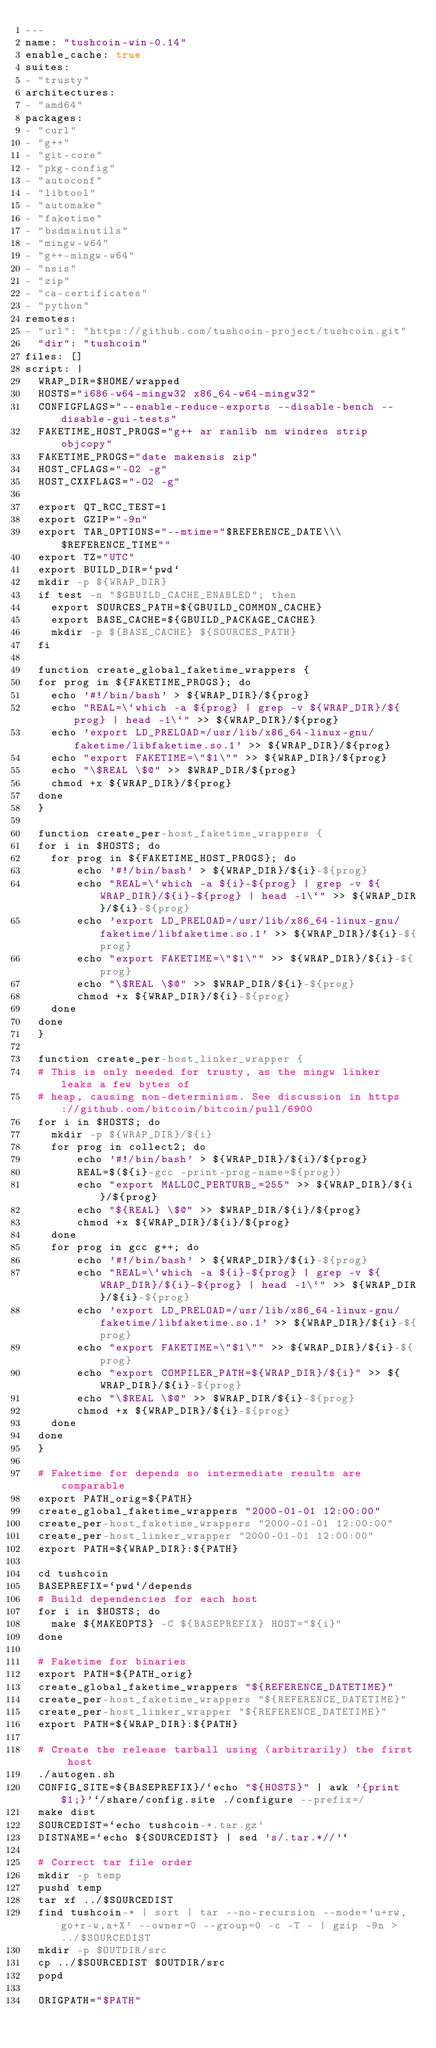<code> <loc_0><loc_0><loc_500><loc_500><_YAML_>---
name: "tushcoin-win-0.14"
enable_cache: true
suites:
- "trusty"
architectures:
- "amd64"
packages:
- "curl"
- "g++"
- "git-core"
- "pkg-config"
- "autoconf"
- "libtool"
- "automake"
- "faketime"
- "bsdmainutils"
- "mingw-w64"
- "g++-mingw-w64"
- "nsis"
- "zip"
- "ca-certificates"
- "python"
remotes:
- "url": "https://github.com/tushcoin-project/tushcoin.git"
  "dir": "tushcoin"
files: []
script: |
  WRAP_DIR=$HOME/wrapped
  HOSTS="i686-w64-mingw32 x86_64-w64-mingw32"
  CONFIGFLAGS="--enable-reduce-exports --disable-bench --disable-gui-tests"
  FAKETIME_HOST_PROGS="g++ ar ranlib nm windres strip objcopy"
  FAKETIME_PROGS="date makensis zip"
  HOST_CFLAGS="-O2 -g"
  HOST_CXXFLAGS="-O2 -g"

  export QT_RCC_TEST=1
  export GZIP="-9n"
  export TAR_OPTIONS="--mtime="$REFERENCE_DATE\\\ $REFERENCE_TIME""
  export TZ="UTC"
  export BUILD_DIR=`pwd`
  mkdir -p ${WRAP_DIR}
  if test -n "$GBUILD_CACHE_ENABLED"; then
    export SOURCES_PATH=${GBUILD_COMMON_CACHE}
    export BASE_CACHE=${GBUILD_PACKAGE_CACHE}
    mkdir -p ${BASE_CACHE} ${SOURCES_PATH}
  fi

  function create_global_faketime_wrappers {
  for prog in ${FAKETIME_PROGS}; do
    echo '#!/bin/bash' > ${WRAP_DIR}/${prog}
    echo "REAL=\`which -a ${prog} | grep -v ${WRAP_DIR}/${prog} | head -1\`" >> ${WRAP_DIR}/${prog}
    echo 'export LD_PRELOAD=/usr/lib/x86_64-linux-gnu/faketime/libfaketime.so.1' >> ${WRAP_DIR}/${prog}
    echo "export FAKETIME=\"$1\"" >> ${WRAP_DIR}/${prog}
    echo "\$REAL \$@" >> $WRAP_DIR/${prog}
    chmod +x ${WRAP_DIR}/${prog}
  done
  }

  function create_per-host_faketime_wrappers {
  for i in $HOSTS; do
    for prog in ${FAKETIME_HOST_PROGS}; do
        echo '#!/bin/bash' > ${WRAP_DIR}/${i}-${prog}
        echo "REAL=\`which -a ${i}-${prog} | grep -v ${WRAP_DIR}/${i}-${prog} | head -1\`" >> ${WRAP_DIR}/${i}-${prog}
        echo 'export LD_PRELOAD=/usr/lib/x86_64-linux-gnu/faketime/libfaketime.so.1' >> ${WRAP_DIR}/${i}-${prog}
        echo "export FAKETIME=\"$1\"" >> ${WRAP_DIR}/${i}-${prog}
        echo "\$REAL \$@" >> $WRAP_DIR/${i}-${prog}
        chmod +x ${WRAP_DIR}/${i}-${prog}
    done
  done
  }

  function create_per-host_linker_wrapper {
  # This is only needed for trusty, as the mingw linker leaks a few bytes of
  # heap, causing non-determinism. See discussion in https://github.com/bitcoin/bitcoin/pull/6900
  for i in $HOSTS; do
    mkdir -p ${WRAP_DIR}/${i}
    for prog in collect2; do
        echo '#!/bin/bash' > ${WRAP_DIR}/${i}/${prog}
        REAL=$(${i}-gcc -print-prog-name=${prog})
        echo "export MALLOC_PERTURB_=255" >> ${WRAP_DIR}/${i}/${prog}
        echo "${REAL} \$@" >> $WRAP_DIR/${i}/${prog}
        chmod +x ${WRAP_DIR}/${i}/${prog}
    done
    for prog in gcc g++; do
        echo '#!/bin/bash' > ${WRAP_DIR}/${i}-${prog}
        echo "REAL=\`which -a ${i}-${prog} | grep -v ${WRAP_DIR}/${i}-${prog} | head -1\`" >> ${WRAP_DIR}/${i}-${prog}
        echo 'export LD_PRELOAD=/usr/lib/x86_64-linux-gnu/faketime/libfaketime.so.1' >> ${WRAP_DIR}/${i}-${prog}
        echo "export FAKETIME=\"$1\"" >> ${WRAP_DIR}/${i}-${prog}
        echo "export COMPILER_PATH=${WRAP_DIR}/${i}" >> ${WRAP_DIR}/${i}-${prog}
        echo "\$REAL \$@" >> $WRAP_DIR/${i}-${prog}
        chmod +x ${WRAP_DIR}/${i}-${prog}
    done
  done
  }

  # Faketime for depends so intermediate results are comparable
  export PATH_orig=${PATH}
  create_global_faketime_wrappers "2000-01-01 12:00:00"
  create_per-host_faketime_wrappers "2000-01-01 12:00:00"
  create_per-host_linker_wrapper "2000-01-01 12:00:00"
  export PATH=${WRAP_DIR}:${PATH}

  cd tushcoin
  BASEPREFIX=`pwd`/depends
  # Build dependencies for each host
  for i in $HOSTS; do
    make ${MAKEOPTS} -C ${BASEPREFIX} HOST="${i}"
  done

  # Faketime for binaries
  export PATH=${PATH_orig}
  create_global_faketime_wrappers "${REFERENCE_DATETIME}"
  create_per-host_faketime_wrappers "${REFERENCE_DATETIME}"
  create_per-host_linker_wrapper "${REFERENCE_DATETIME}"
  export PATH=${WRAP_DIR}:${PATH}

  # Create the release tarball using (arbitrarily) the first host
  ./autogen.sh
  CONFIG_SITE=${BASEPREFIX}/`echo "${HOSTS}" | awk '{print $1;}'`/share/config.site ./configure --prefix=/
  make dist
  SOURCEDIST=`echo tushcoin-*.tar.gz`
  DISTNAME=`echo ${SOURCEDIST} | sed 's/.tar.*//'`

  # Correct tar file order
  mkdir -p temp
  pushd temp
  tar xf ../$SOURCEDIST
  find tushcoin-* | sort | tar --no-recursion --mode='u+rw,go+r-w,a+X' --owner=0 --group=0 -c -T - | gzip -9n > ../$SOURCEDIST
  mkdir -p $OUTDIR/src
  cp ../$SOURCEDIST $OUTDIR/src
  popd

  ORIGPATH="$PATH"</code> 